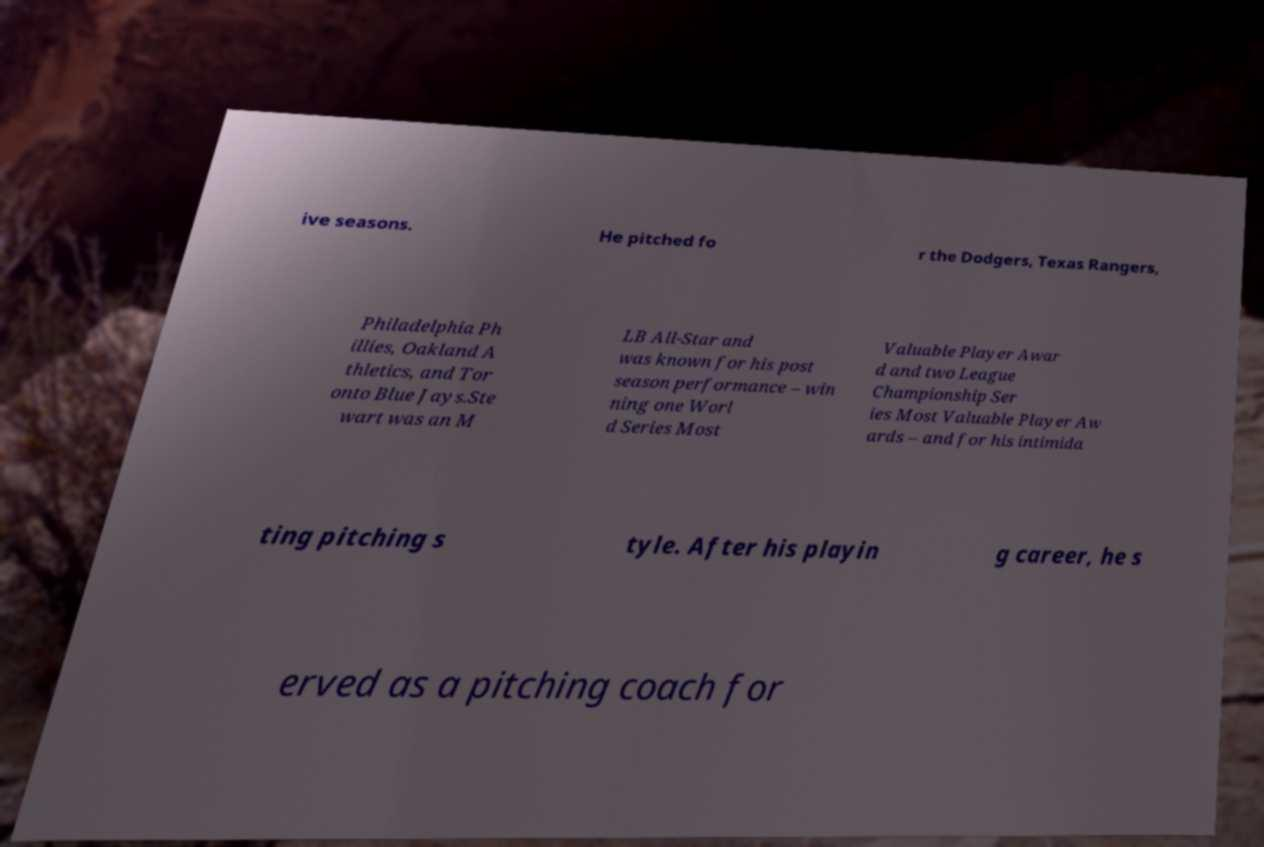Could you assist in decoding the text presented in this image and type it out clearly? ive seasons. He pitched fo r the Dodgers, Texas Rangers, Philadelphia Ph illies, Oakland A thletics, and Tor onto Blue Jays.Ste wart was an M LB All-Star and was known for his post season performance – win ning one Worl d Series Most Valuable Player Awar d and two League Championship Ser ies Most Valuable Player Aw ards – and for his intimida ting pitching s tyle. After his playin g career, he s erved as a pitching coach for 